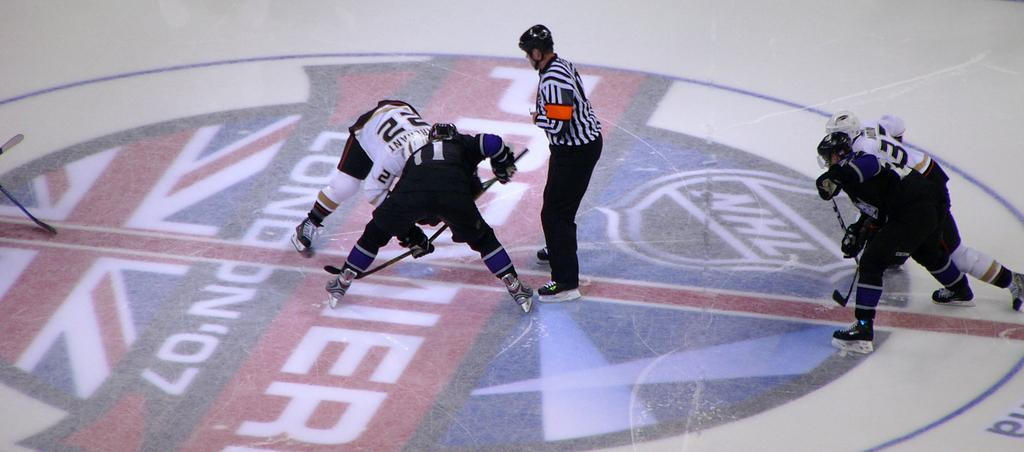What are the people holding in their hands in the image? The people are holding sticks in their hands. What type of footwear are the people wearing? The people are wearing skating shoes. Can you describe the person standing on the path? There is a person standing on a path in the image. What is the unusual object on the floor in the image? There is a painting on the floor in the image. What type of hydrant is present in the image? There is no hydrant present in the image. What is the cause of the temper displayed by the people in the image? There is no indication of temper or protest in the image; the people are simply holding sticks and wearing skating shoes. 